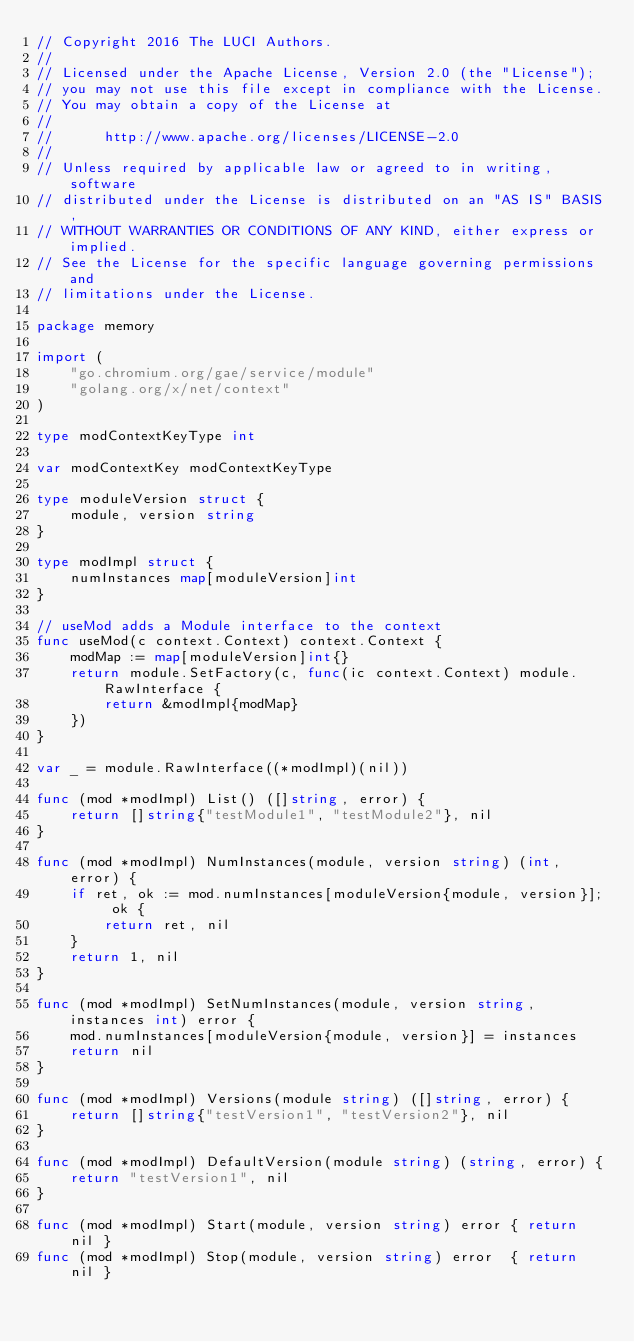<code> <loc_0><loc_0><loc_500><loc_500><_Go_>// Copyright 2016 The LUCI Authors.
//
// Licensed under the Apache License, Version 2.0 (the "License");
// you may not use this file except in compliance with the License.
// You may obtain a copy of the License at
//
//      http://www.apache.org/licenses/LICENSE-2.0
//
// Unless required by applicable law or agreed to in writing, software
// distributed under the License is distributed on an "AS IS" BASIS,
// WITHOUT WARRANTIES OR CONDITIONS OF ANY KIND, either express or implied.
// See the License for the specific language governing permissions and
// limitations under the License.

package memory

import (
	"go.chromium.org/gae/service/module"
	"golang.org/x/net/context"
)

type modContextKeyType int

var modContextKey modContextKeyType

type moduleVersion struct {
	module, version string
}

type modImpl struct {
	numInstances map[moduleVersion]int
}

// useMod adds a Module interface to the context
func useMod(c context.Context) context.Context {
	modMap := map[moduleVersion]int{}
	return module.SetFactory(c, func(ic context.Context) module.RawInterface {
		return &modImpl{modMap}
	})
}

var _ = module.RawInterface((*modImpl)(nil))

func (mod *modImpl) List() ([]string, error) {
	return []string{"testModule1", "testModule2"}, nil
}

func (mod *modImpl) NumInstances(module, version string) (int, error) {
	if ret, ok := mod.numInstances[moduleVersion{module, version}]; ok {
		return ret, nil
	}
	return 1, nil
}

func (mod *modImpl) SetNumInstances(module, version string, instances int) error {
	mod.numInstances[moduleVersion{module, version}] = instances
	return nil
}

func (mod *modImpl) Versions(module string) ([]string, error) {
	return []string{"testVersion1", "testVersion2"}, nil
}

func (mod *modImpl) DefaultVersion(module string) (string, error) {
	return "testVersion1", nil
}

func (mod *modImpl) Start(module, version string) error { return nil }
func (mod *modImpl) Stop(module, version string) error  { return nil }
</code> 